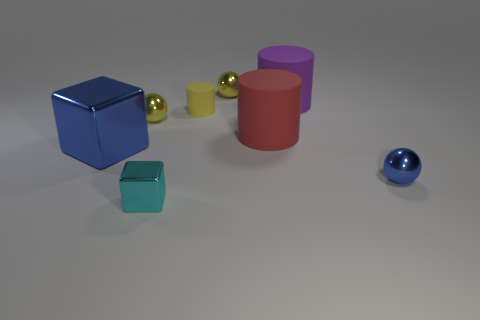Subtract all yellow balls. How many were subtracted if there are1yellow balls left? 1 Add 1 small yellow cubes. How many objects exist? 9 Subtract all blue metal spheres. How many spheres are left? 2 Subtract all spheres. How many objects are left? 5 Subtract all purple cylinders. How many cylinders are left? 2 Subtract all blue cubes. How many brown cylinders are left? 0 Subtract all red matte cylinders. Subtract all small cyan metallic things. How many objects are left? 6 Add 1 cyan objects. How many cyan objects are left? 2 Add 4 yellow matte cylinders. How many yellow matte cylinders exist? 5 Subtract 0 gray balls. How many objects are left? 8 